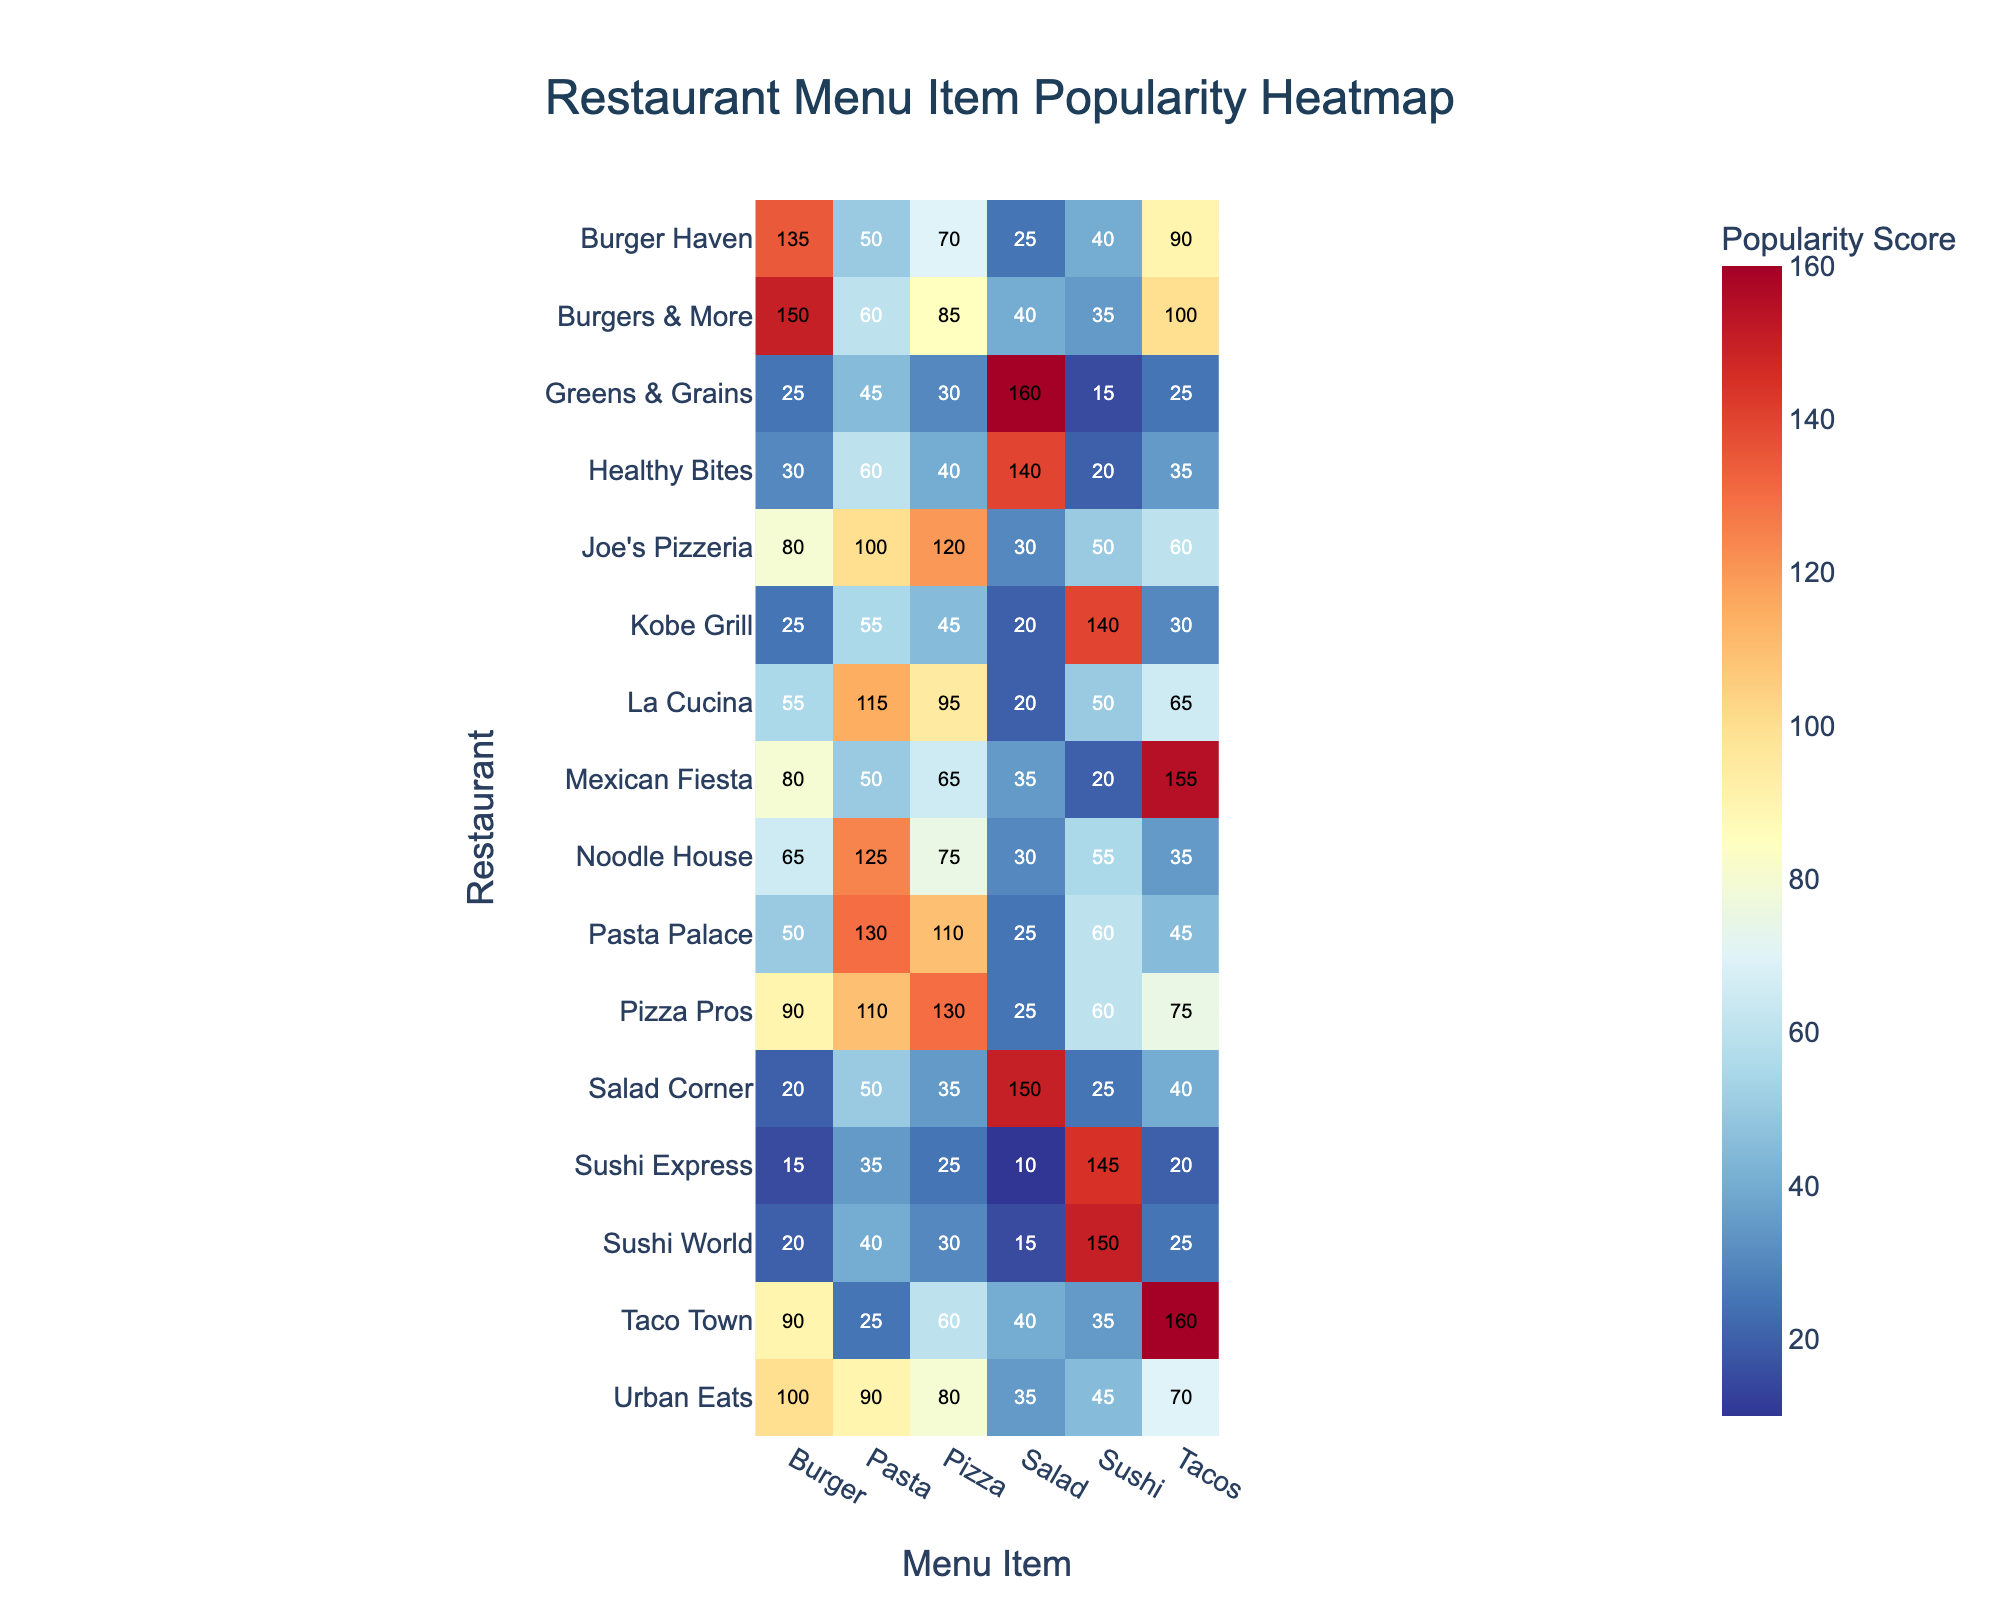What is the most popular menu item at Joe's Pizzeria? Visual inspection of the heatmap shows that the most popular menu item at Joe's Pizzeria has the highest value, which is for Pizza with a popularity score of 120.
Answer: Pizza Which restaurant in Downtown has the highest popularity score for Burgers? By examining the heatmap, the highest popularity score for Burgers in Downtown is at Urban Eats with a score of 100.
Answer: Urban Eats How does the popularity of Sushi at Sushi Express compare to Kobe Grill? Looking at the heatmap, Sushi Express has a Sushi popularity score of 145, while Kobe Grill has a score of 140, making Sushi more popular at Sushi Express.
Answer: Sushi Express Which restaurant has the lowest popularity score for Salad in the West End neighborhood? In the West End neighborhood, the restaurant with the lowest Salad popularity score is Healthy Bites with a score of 140.
Answer: Healthy Bites Is Pasta more popular in East Side or Southside? Comparing the popularity scores for Pasta, East Side's Pasta Palace has the highest score of 130, whereas Southside's top spot, Mexican Fiesta, has a score of 50. Thus, Pasta is more popular in East Side.
Answer: East Side What is the average popularity score of Tacos across all restaurants? Summing up the Tacos popularity scores (60, 90, 25, 35, 45, 160, 70, 65, 30, 25, 35, 155, 75, 100, 20, and 40) gives 1030. Dividing this by the number of restaurants (16) results in an average score of approximately 64.375.
Answer: ~64.375 Which menu item has the highest average popularity score across all restaurants? To determine this, average the scores of each menu item across all restaurants. The menu item with the highest cumulative score will have the highest average. When calculated: Pizza: (120+70+30+40+110+60+80+95+45+30+75+65+130+85+25+35) / 16 = 67.19; Burger: 76.88; Sushi: 56.25; Salad: 50.31; Pasta: 78.125; and Tacos: 65.63. Pasta has the highest average popularity score.
Answer: Pasta What's the difference in popularity score for Burgers between Burger Haven and Greens & Grains? Burger Haven in Midtown has a Burger popularity score of 135 and Greens & Grains in West End has a score of 25. The difference is 135 - 25 = 110.
Answer: 110 